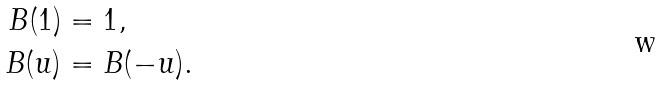<formula> <loc_0><loc_0><loc_500><loc_500>B ( 1 ) & = 1 , \\ B ( u ) & = B ( - u ) .</formula> 